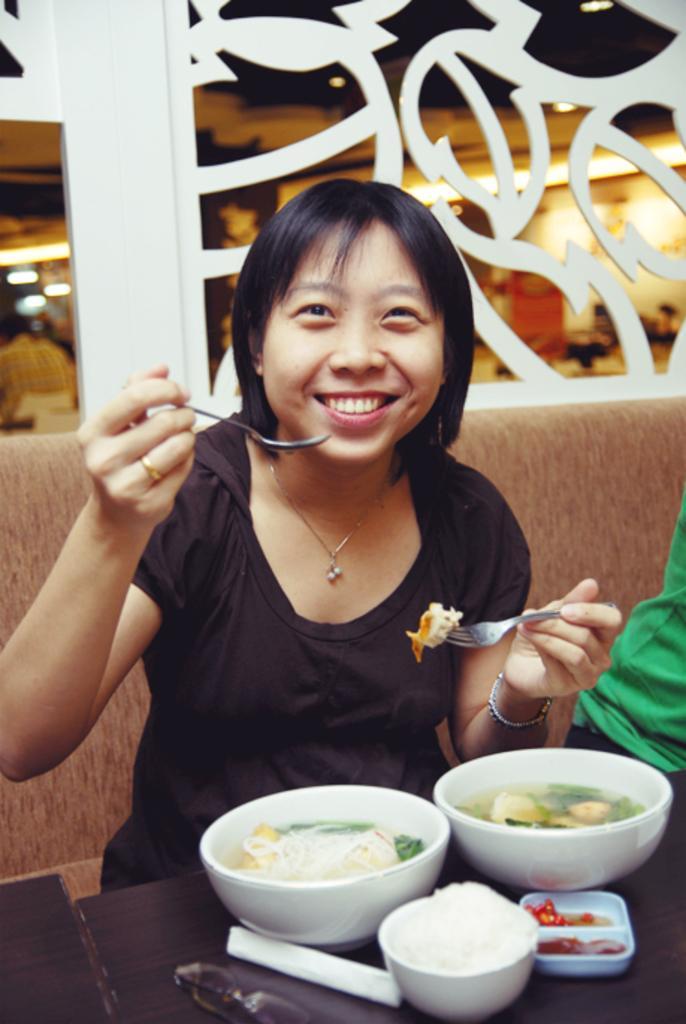Can you describe this image briefly? In this image we can see two persons sitting on the couch, a person is holding a spoon and a fork and there are few bowls with food items on the table in front of the person and a wall with design in the background. 